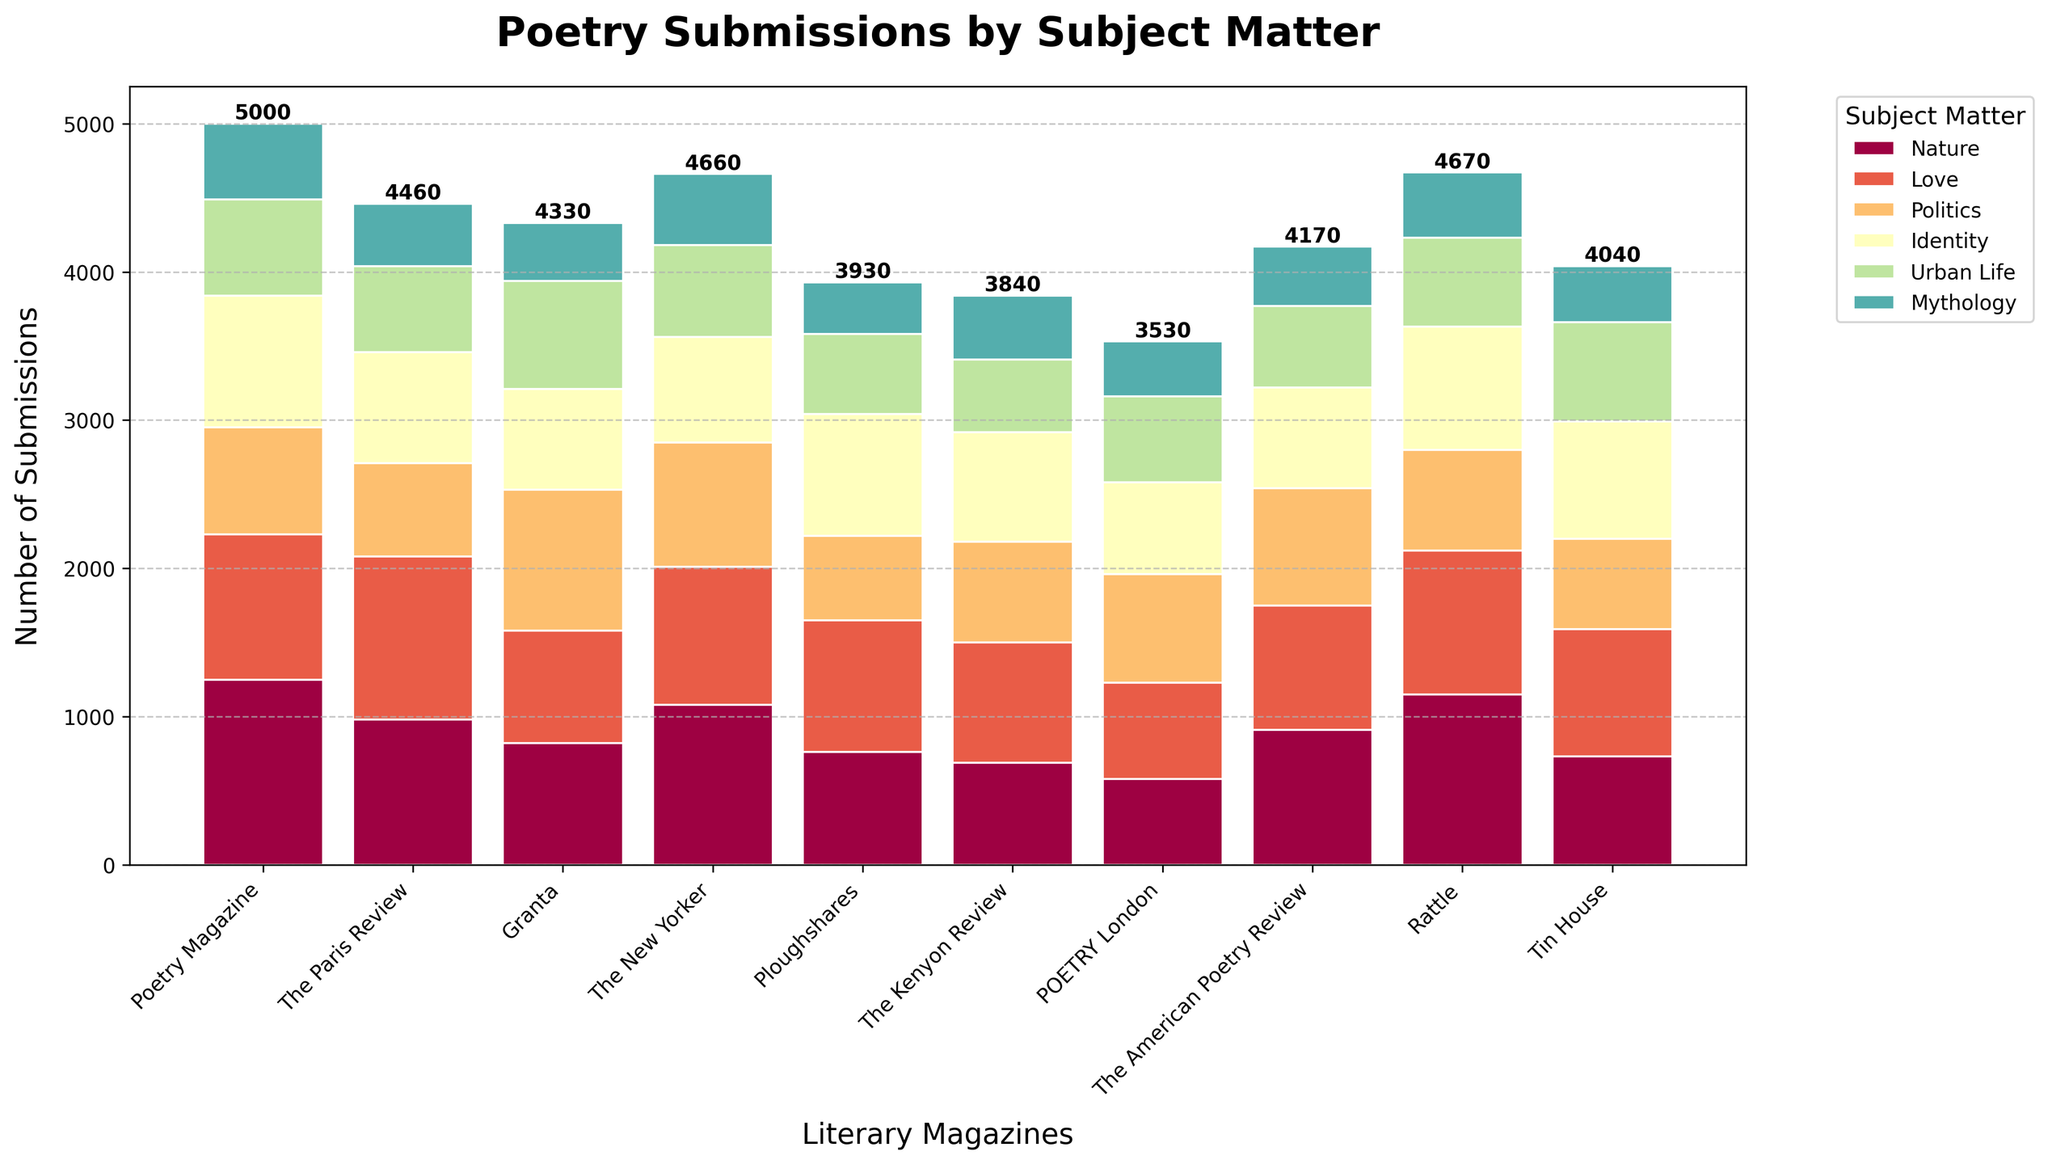Which magazine received the most submissions in the category of Nature? By visually inspecting the tallest bars, the bar for "Poetry Magazine" in the Nature category is the tallest.
Answer: Poetry Magazine Which category had the fewest submissions across all magazines? To answer this, summing the values for each category across all magazines reveals that 'Mythology' consistently has lower values compared to others.
Answer: Mythology How does the number of Love-themed submissions to The Paris Review compare to The New Yorker? Looking at the corresponding bars, The Paris Review received more Love-themed submissions (1100) compared to The New Yorker (930).
Answer: The Paris Review received more Which magazine had the highest number of Identity-themed submissions? By comparing the height of the bars in the Identity category, Granta has the tallest bar with 950 submissions.
Answer: Granta What is the total number of submissions Poetry Magazine received for all categories combined? Summing up the values for Poetry Magazine (1250+980+720+890+650+510) results in a total of 5000 submissions.
Answer: 5000 Which magazine had the least submissions in the Urban Life category, and how many were there? Examining the bars, The Kenyon Review had the least submissions with a bar height corresponding to 490.
Answer: The Kenyon Review with 490 Are there any magazines that received more Politics submissions than Nature submissions? By comparing the heights of the bars in Politics and Nature categories, Granta had more Politics (950) than Nature (820).
Answer: Granta How many more Mythology submissions did The New Yorker receive compared to Ploughshares? Calculating the difference: The New Yorker (480), Ploughshares (350); therefore, 480 - 350 = 130.
Answer: 130 Rank the magazines by the total number of Urban Life submissions in descending order. Count the total Urban Life submissions for each magazine and rank: Poetry Magazine (650), Tin House (670), Granta (730), and so on.
Answer: Granta, Tin House, Poetry Magazine, The New Yorker, Rattle, The American Poetry Review, Ploughshares, The Paris Review, POETRY London, The Kenyon Review What is the average number of Nature-themed submissions across all magazines? Summing up Nature submissions (1250+980+820+1080+760+690+580+910+1150+730) and dividing by 10 gives an average: (8950/10)
Answer: 895 